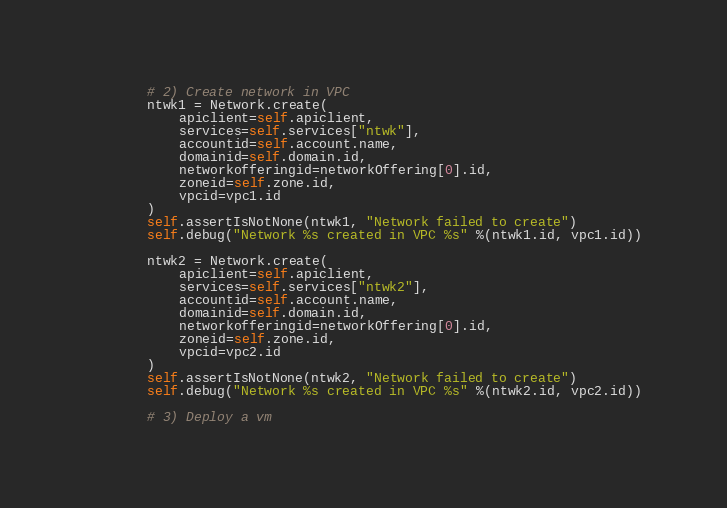Convert code to text. <code><loc_0><loc_0><loc_500><loc_500><_Python_>
        # 2) Create network in VPC
        ntwk1 = Network.create(
            apiclient=self.apiclient,
            services=self.services["ntwk"],
            accountid=self.account.name,
            domainid=self.domain.id,
            networkofferingid=networkOffering[0].id,
            zoneid=self.zone.id,
            vpcid=vpc1.id
        )
        self.assertIsNotNone(ntwk1, "Network failed to create")
        self.debug("Network %s created in VPC %s" %(ntwk1.id, vpc1.id))

        ntwk2 = Network.create(
            apiclient=self.apiclient,
            services=self.services["ntwk2"],
            accountid=self.account.name,
            domainid=self.domain.id,
            networkofferingid=networkOffering[0].id,
            zoneid=self.zone.id,
            vpcid=vpc2.id
        )
        self.assertIsNotNone(ntwk2, "Network failed to create")
        self.debug("Network %s created in VPC %s" %(ntwk2.id, vpc2.id))

        # 3) Deploy a vm</code> 